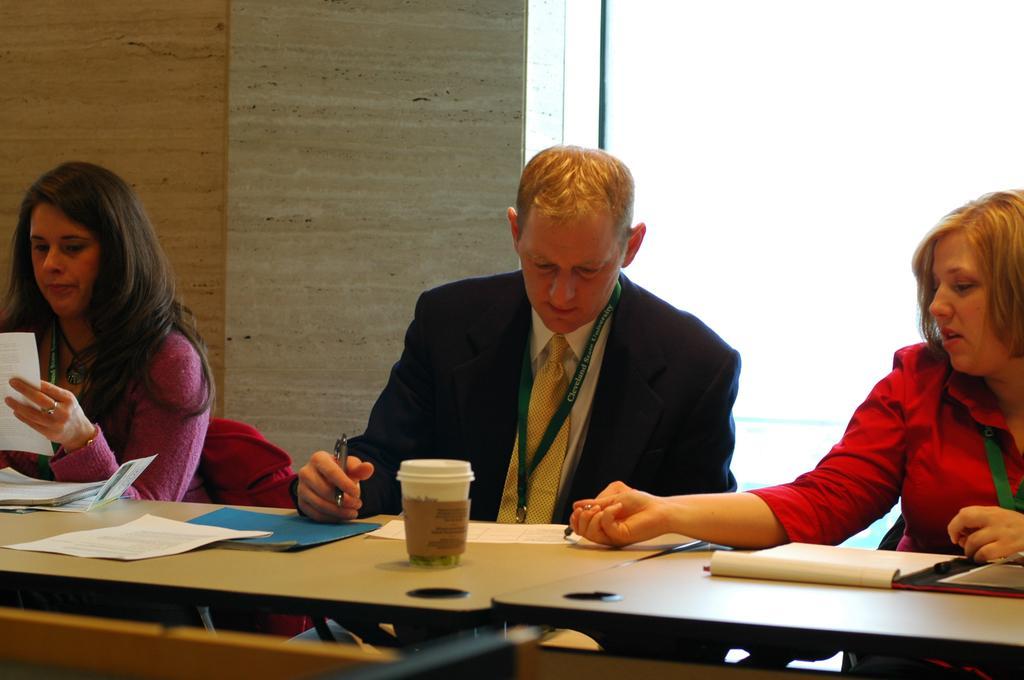Please provide a concise description of this image. In this picture, we see two women and a man seated on the chair And there is a table in front of them. On the table, we can see a coffee cup and papers. 